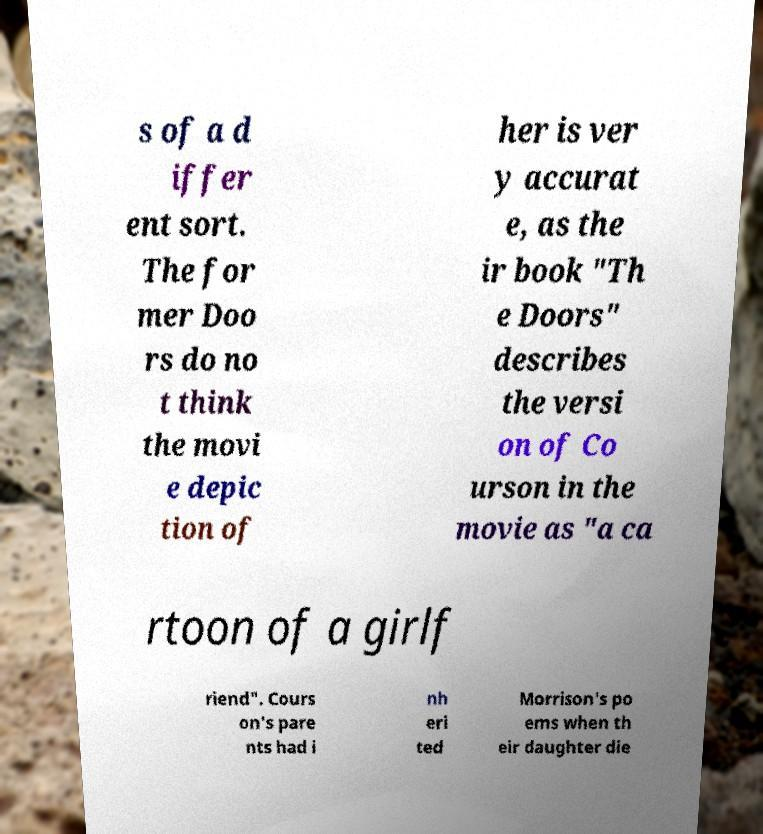Please read and relay the text visible in this image. What does it say? s of a d iffer ent sort. The for mer Doo rs do no t think the movi e depic tion of her is ver y accurat e, as the ir book "Th e Doors" describes the versi on of Co urson in the movie as "a ca rtoon of a girlf riend". Cours on's pare nts had i nh eri ted Morrison's po ems when th eir daughter die 